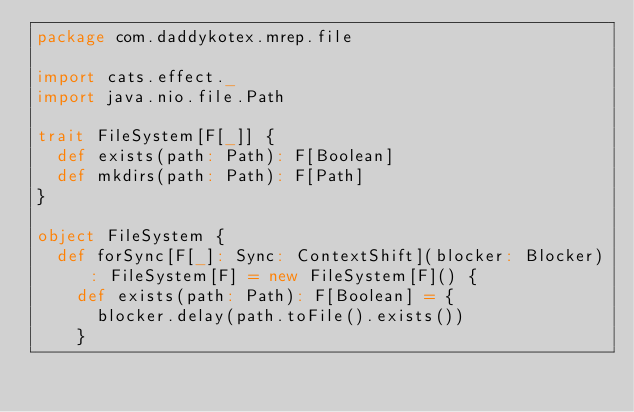Convert code to text. <code><loc_0><loc_0><loc_500><loc_500><_Scala_>package com.daddykotex.mrep.file

import cats.effect._
import java.nio.file.Path

trait FileSystem[F[_]] {
  def exists(path: Path): F[Boolean]
  def mkdirs(path: Path): F[Path]
}

object FileSystem {
  def forSync[F[_]: Sync: ContextShift](blocker: Blocker): FileSystem[F] = new FileSystem[F]() {
    def exists(path: Path): F[Boolean] = {
      blocker.delay(path.toFile().exists())
    }</code> 